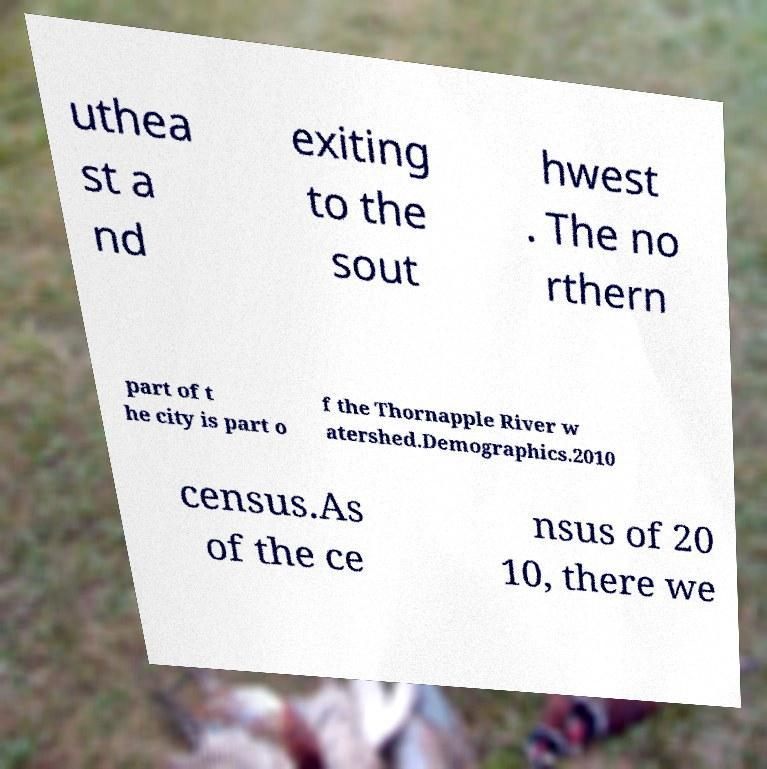Could you assist in decoding the text presented in this image and type it out clearly? uthea st a nd exiting to the sout hwest . The no rthern part of t he city is part o f the Thornapple River w atershed.Demographics.2010 census.As of the ce nsus of 20 10, there we 